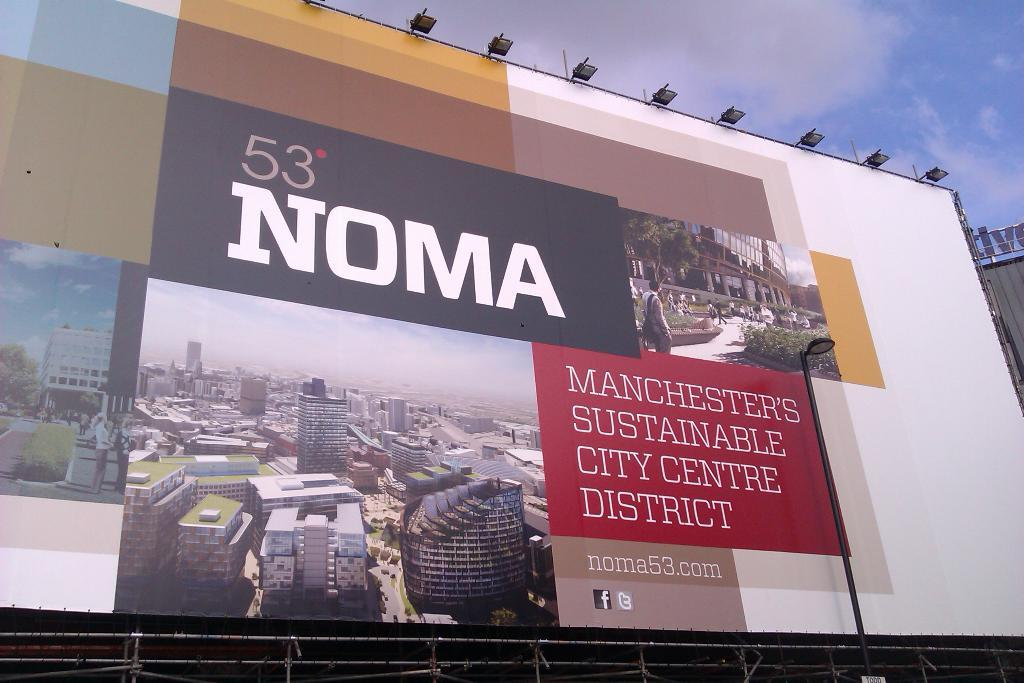<image>
Create a compact narrative representing the image presented. a sign for NOMA talks about the sustainable district there 